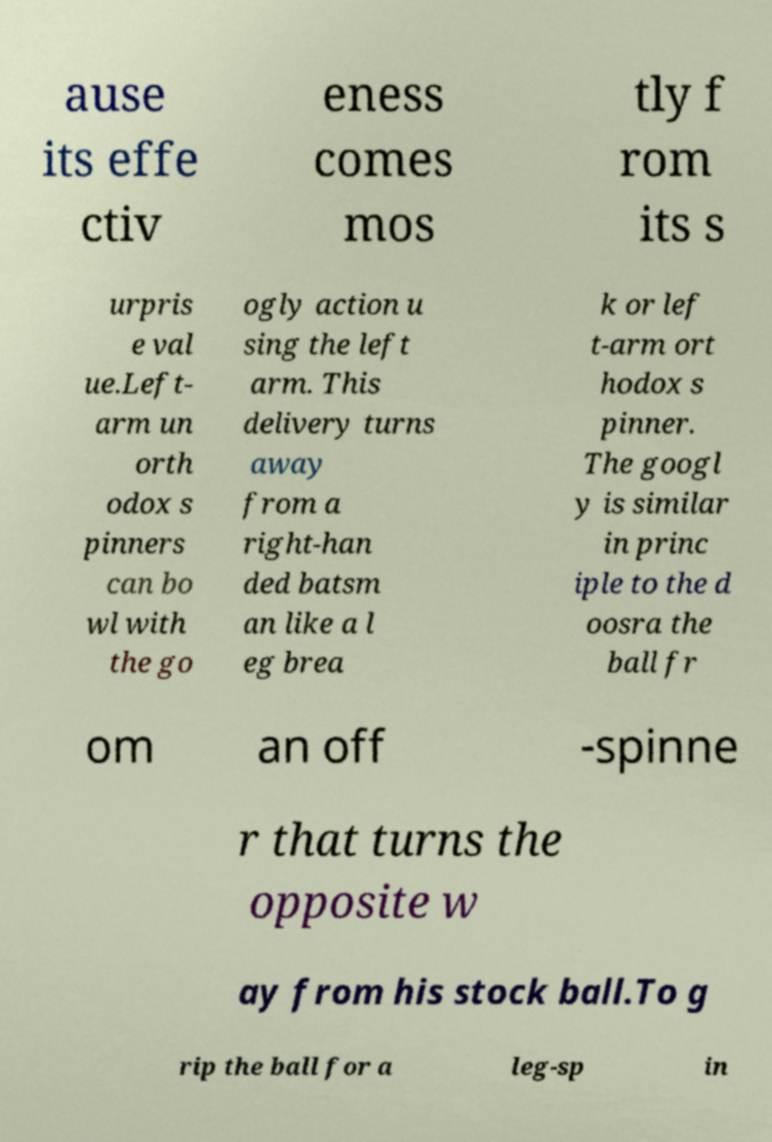Can you accurately transcribe the text from the provided image for me? ause its effe ctiv eness comes mos tly f rom its s urpris e val ue.Left- arm un orth odox s pinners can bo wl with the go ogly action u sing the left arm. This delivery turns away from a right-han ded batsm an like a l eg brea k or lef t-arm ort hodox s pinner. The googl y is similar in princ iple to the d oosra the ball fr om an off -spinne r that turns the opposite w ay from his stock ball.To g rip the ball for a leg-sp in 